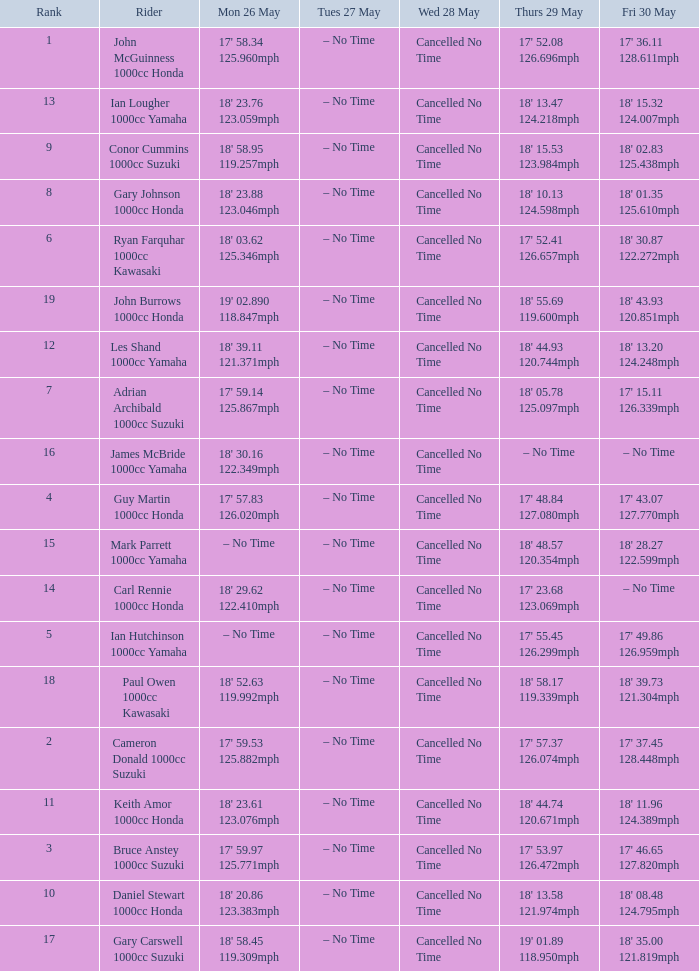What time is mon may 26 and fri may 30 is 18' 28.27 122.599mph? – No Time. 